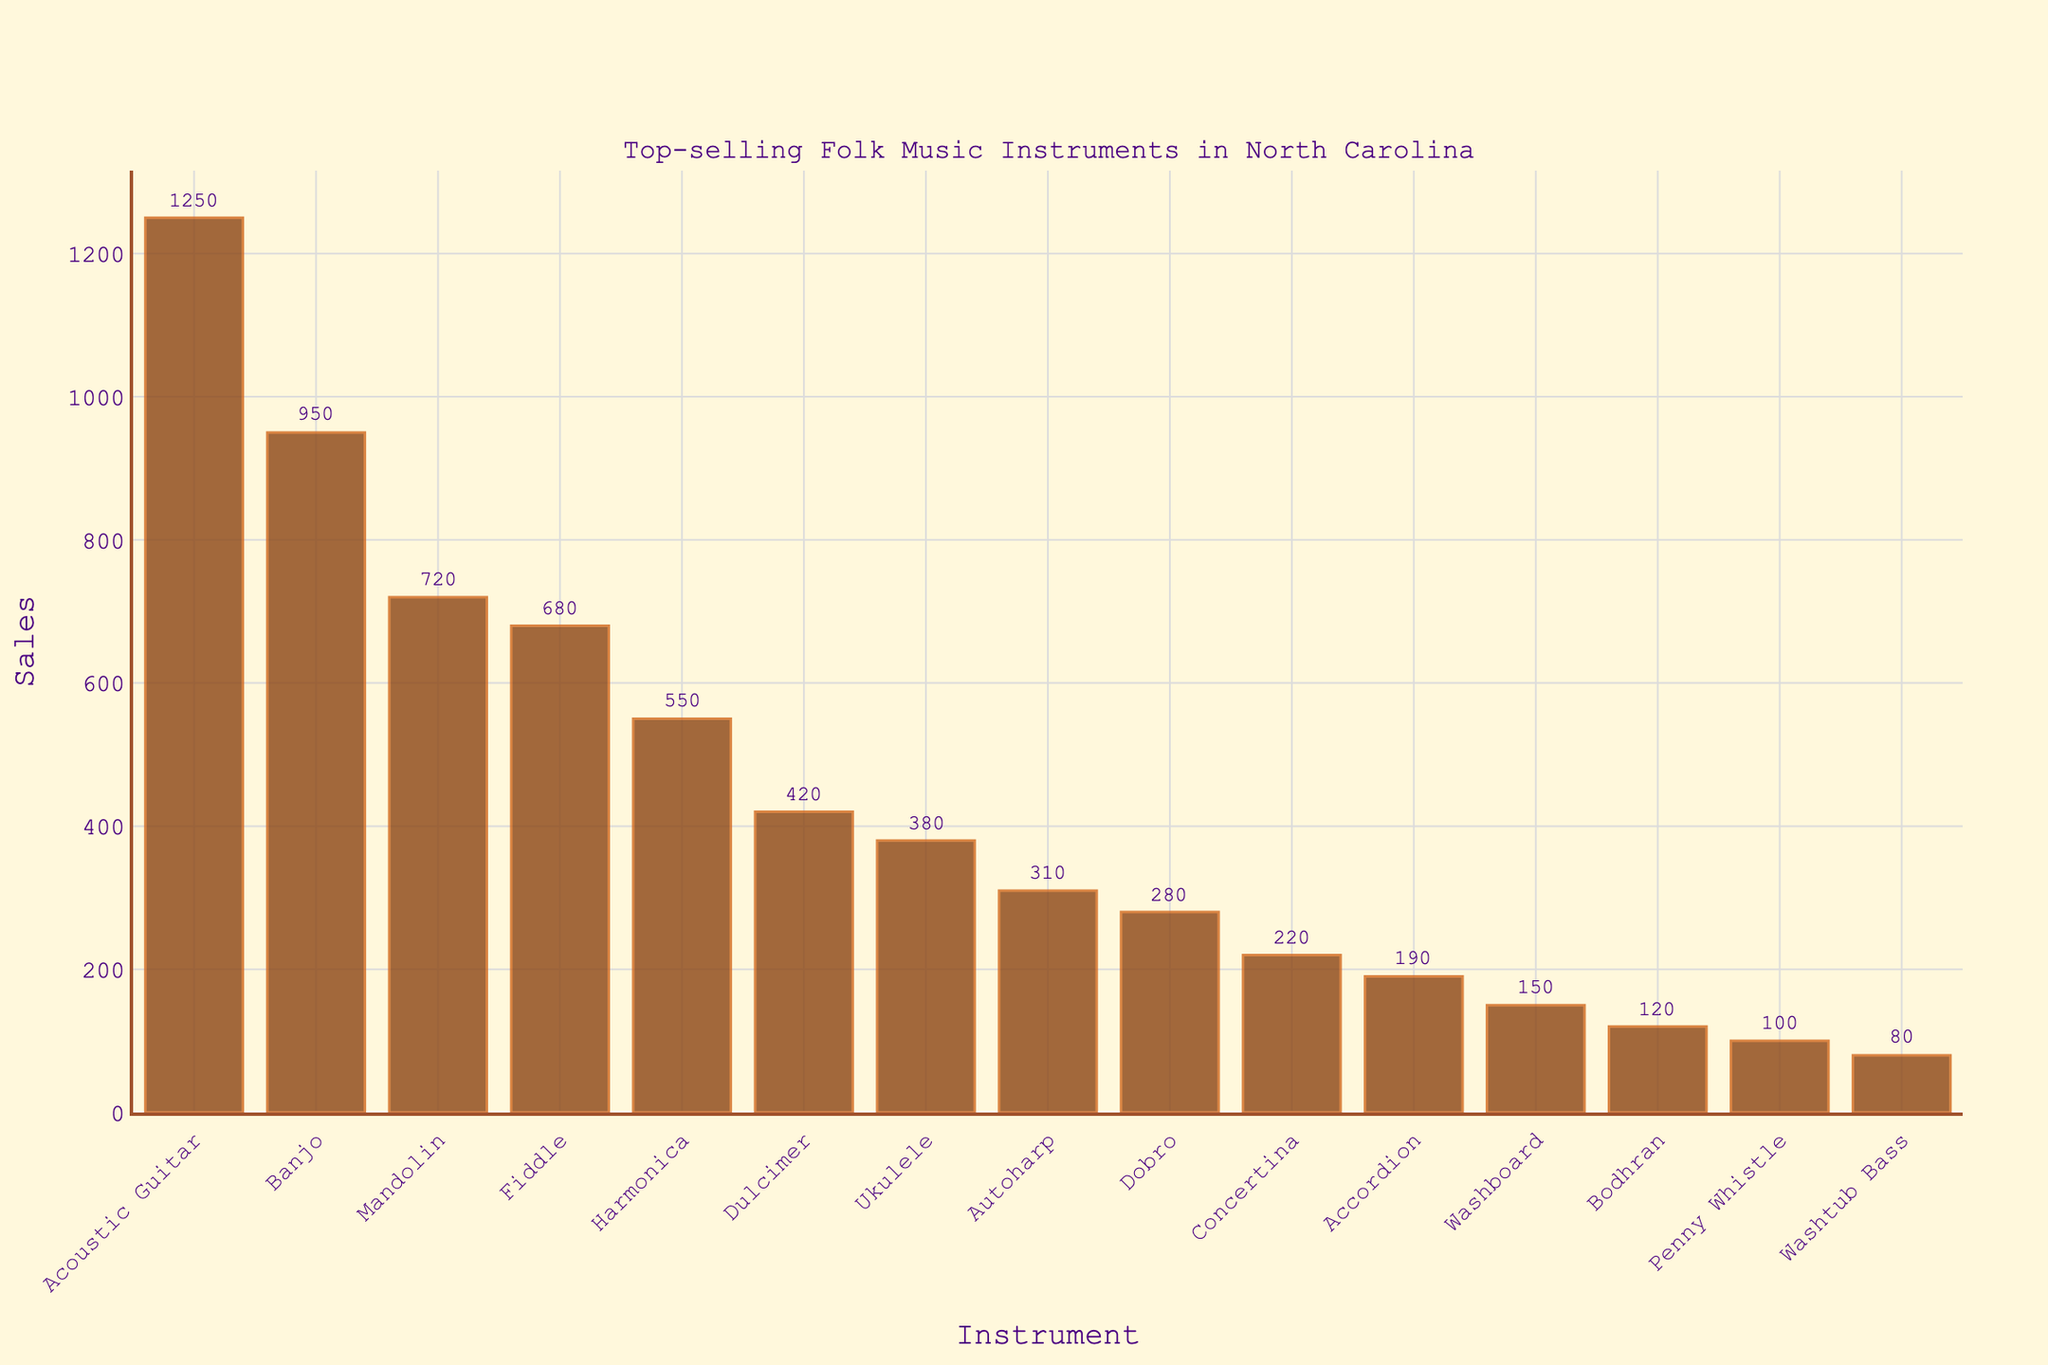What's the top-selling folk music instrument in North Carolina music stores? The bar chart shows the instrument with the highest sales number. The Acoustic Guitar has the tallest bar.
Answer: Acoustic Guitar Which instrument has the second-highest sales? By examining the bars from the highest to the second-highest, the Banjo has the next tallest bar after the Acoustic Guitar.
Answer: Banjo What is the total sales of Mandolins and Fiddles? Add the sales numbers for Mandolins (720) and Fiddles (680). 720 + 680 = 1400.
Answer: 1400 How does the sales of Harmonicas compare to Dulcimers? Compare the height of the bars for Harmonicas and Dulcimers. The Harmonica bar is higher than the Dulcimer bar.
Answer: Higher What is the average sales of Ukuleles, Autoharps, and Dobros? Add the sales of Ukuleles (380), Autoharps (310), and Dobros (280), then divide by 3. (380 + 310 + 280) / 3 = 323.33.
Answer: 323.33 Which instrument has the lowest sales? The bar with the smallest height represents the instrument with the lowest sales. The Washtub Bass has the lowest sales number.
Answer: Washtub Bass Are sales for Banjos greater than the combined sales of Concertinas and Accordions? Compare the sales number for Banjos (950) with the sum of Concertinas (220) and Accordions (190). 220 + 190 = 410, and 950 > 410.
Answer: Yes What is the difference in sales between the Accordion and the Concertina? Subtract the sales number for the Concertina from that of the Accordion. 220 - 190 = 30.
Answer: 30 How much higher are the sales for Acoustic Guitars compared to the total sales for Penny Whistles and Bodhrans? Sum the sales for Penny Whistles (100) and Bodhrans (120), then subtract from the Acoustic Guitar sales. 1250 - (100 + 120) = 1030.
Answer: 1030 What is the sales difference between the Fiddle and the Harmonica? Subtract the Harmonica sales from the Fiddle sales. 680 - 550 = 130.
Answer: 130 